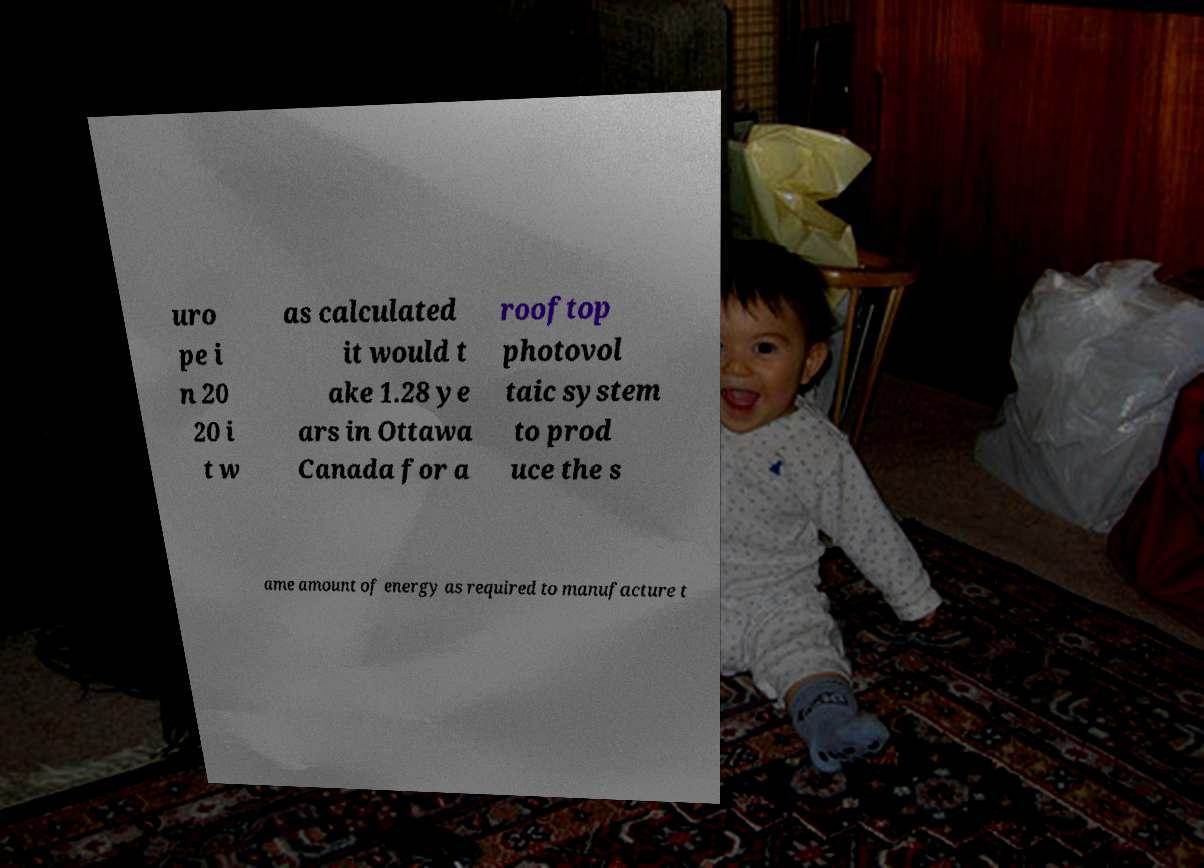Can you accurately transcribe the text from the provided image for me? uro pe i n 20 20 i t w as calculated it would t ake 1.28 ye ars in Ottawa Canada for a rooftop photovol taic system to prod uce the s ame amount of energy as required to manufacture t 